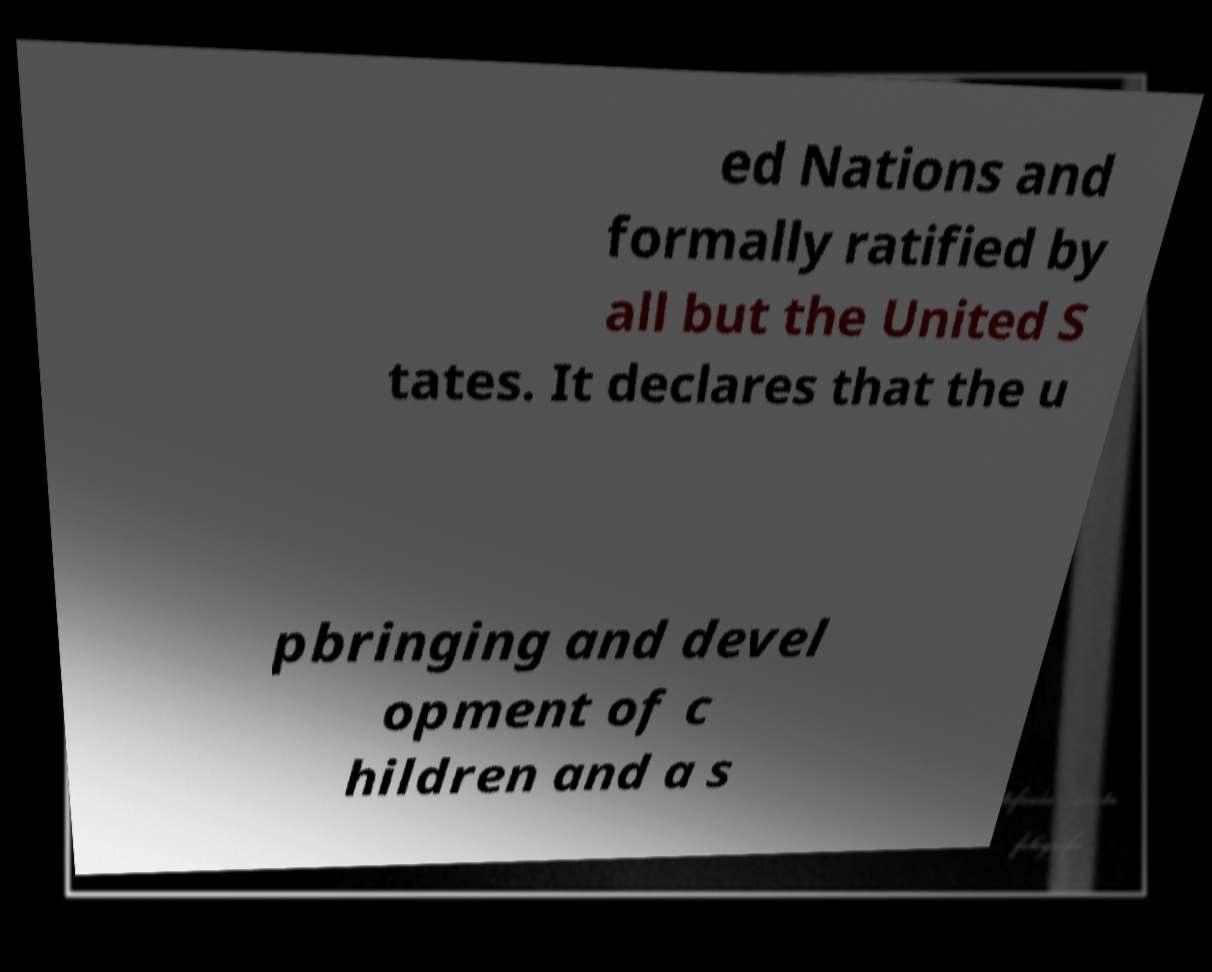I need the written content from this picture converted into text. Can you do that? ed Nations and formally ratified by all but the United S tates. It declares that the u pbringing and devel opment of c hildren and a s 